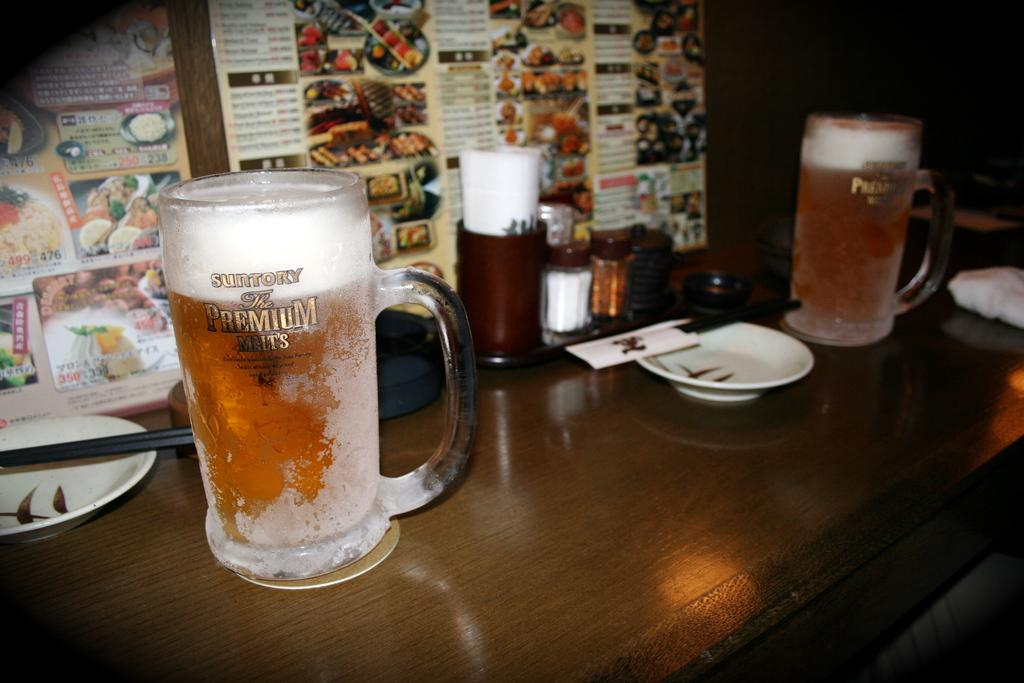<image>
Offer a succinct explanation of the picture presented. A couple beers sitting on a table with a menu behind them and the one beer says Suntory The Premium Malts on it. 